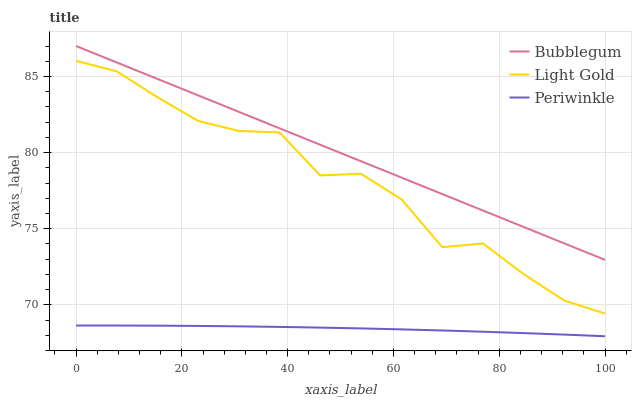Does Periwinkle have the minimum area under the curve?
Answer yes or no. Yes. Does Bubblegum have the maximum area under the curve?
Answer yes or no. Yes. Does Light Gold have the minimum area under the curve?
Answer yes or no. No. Does Light Gold have the maximum area under the curve?
Answer yes or no. No. Is Bubblegum the smoothest?
Answer yes or no. Yes. Is Light Gold the roughest?
Answer yes or no. Yes. Is Light Gold the smoothest?
Answer yes or no. No. Is Bubblegum the roughest?
Answer yes or no. No. Does Periwinkle have the lowest value?
Answer yes or no. Yes. Does Light Gold have the lowest value?
Answer yes or no. No. Does Bubblegum have the highest value?
Answer yes or no. Yes. Does Light Gold have the highest value?
Answer yes or no. No. Is Periwinkle less than Light Gold?
Answer yes or no. Yes. Is Bubblegum greater than Periwinkle?
Answer yes or no. Yes. Does Periwinkle intersect Light Gold?
Answer yes or no. No. 